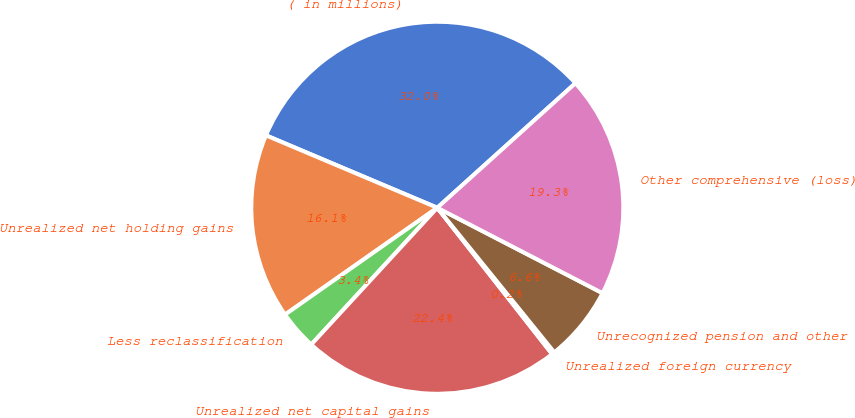<chart> <loc_0><loc_0><loc_500><loc_500><pie_chart><fcel>( in millions)<fcel>Unrealized net holding gains<fcel>Less reclassification<fcel>Unrealized net capital gains<fcel>Unrealized foreign currency<fcel>Unrecognized pension and other<fcel>Other comprehensive (loss)<nl><fcel>31.96%<fcel>16.1%<fcel>3.41%<fcel>22.44%<fcel>0.24%<fcel>6.58%<fcel>19.27%<nl></chart> 